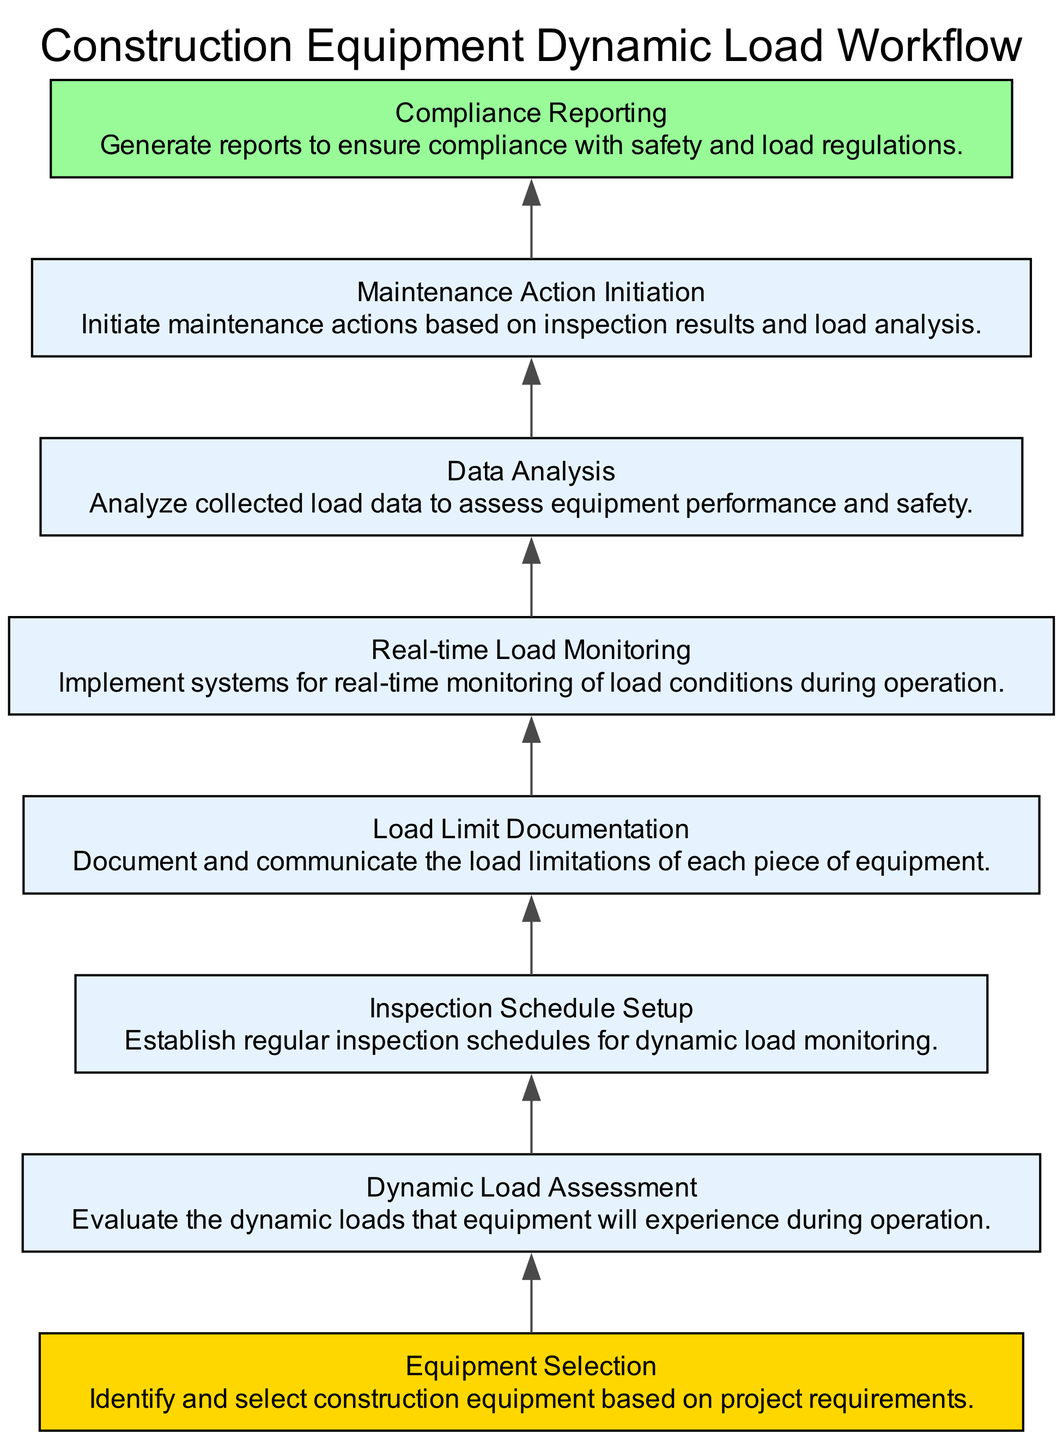What is the first step in the workflow? The first step in the workflow, represented in the diagram, is "Equipment Selection", which is located at the top of the flowchart.
Answer: Equipment Selection How many nodes are in the diagram? By counting the boxed elements in the flowchart, there are a total of eight distinct nodes listed in the workflow.
Answer: 8 What does the "Real-time Load Monitoring" node connect to? The "Real-time Load Monitoring" node directly funnels into the "Data Analysis" node, which indicates that load data is analyzed after real-time monitoring.
Answer: Data Analysis Which part of the workflow is responsible for generating compliance documentation? The "Compliance Reporting" node, positioned at the end of the flowchart, is responsible for generating reports related to compliance, as detailed in its description.
Answer: Compliance Reporting What is the last action taken in the workflow? The last action in the workflow is represented by the "Compliance Reporting" node, which indicates that this is the endpoint of the process involving monitoring and maintaining dynamic loads.
Answer: Compliance Reporting How does "Dynamic Load Assessment" relate to "Maintenance Action Initiation"? "Dynamic Load Assessment" informs and precedes "Maintenance Action Initiation" in the workflow, as proper assessment is essential before initiating maintenance actions based on the results.
Answer: Dynamic Load Assessment informs Maintenance Action Initiation What is the purpose of "Load Limit Documentation"? The "Load Limit Documentation" node serves the purpose of communicating the load limitations pertaining to each piece of equipment, underlining its importance in the safety and regulatory context.
Answer: Communicate load limitations Which phase precedes "Data Analysis"? The "Real-time Load Monitoring" phase is conducted before "Data Analysis", indicating that real-time data needs to be gathered prior to analysis in the workflow.
Answer: Real-time Load Monitoring 